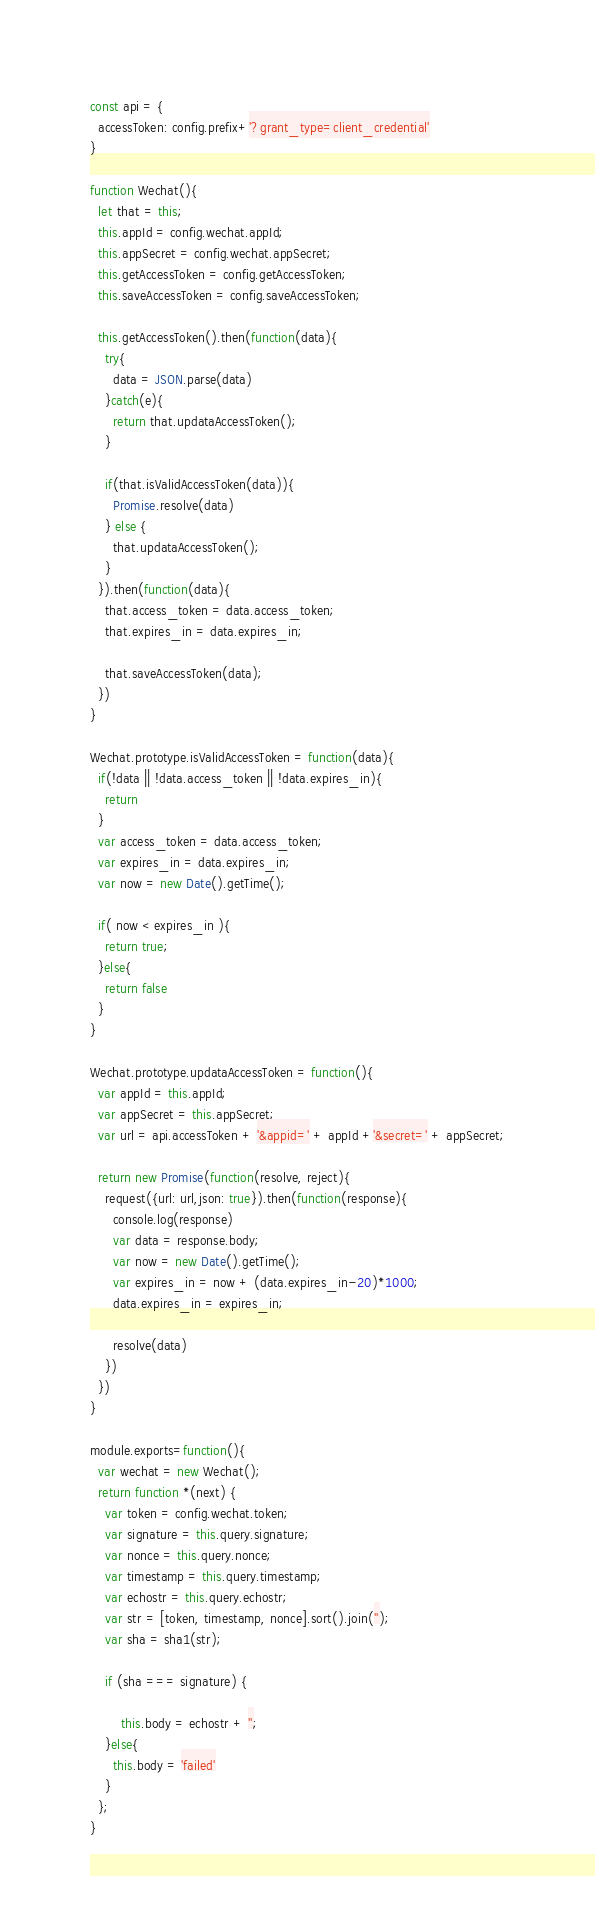Convert code to text. <code><loc_0><loc_0><loc_500><loc_500><_JavaScript_>
const api = {
  accessToken: config.prefix+'?grant_type=client_credential'
}

function Wechat(){
  let that = this;
  this.appId = config.wechat.appId;
  this.appSecret = config.wechat.appSecret;
  this.getAccessToken = config.getAccessToken;
  this.saveAccessToken = config.saveAccessToken;

  this.getAccessToken().then(function(data){
    try{
      data = JSON.parse(data)
    }catch(e){
      return that.updataAccessToken();
    }

    if(that.isValidAccessToken(data)){
      Promise.resolve(data)
    } else {
      that.updataAccessToken();
    }
  }).then(function(data){
    that.access_token = data.access_token;
    that.expires_in = data.expires_in;

    that.saveAccessToken(data);
  })
}

Wechat.prototype.isValidAccessToken = function(data){
  if(!data || !data.access_token || !data.expires_in){
    return 
  }
  var access_token = data.access_token;
  var expires_in = data.expires_in;
  var now = new Date().getTime();

  if( now < expires_in ){
    return true;
  }else{
    return false
  }
}

Wechat.prototype.updataAccessToken = function(){
  var appId = this.appId;
  var appSecret = this.appSecret;
  var url = api.accessToken + '&appid=' + appId +'&secret=' + appSecret;

  return new Promise(function(resolve, reject){
    request({url: url,json: true}).then(function(response){
      console.log(response)
      var data = response.body;
      var now = new Date().getTime();
      var expires_in = now + (data.expires_in-20)*1000;
      data.expires_in = expires_in;

      resolve(data)
    })
  })
}

module.exports=function(){
  var wechat = new Wechat();
  return function *(next) {
    var token = config.wechat.token;
    var signature = this.query.signature;
    var nonce = this.query.nonce;
    var timestamp = this.query.timestamp;
    var echostr = this.query.echostr;
    var str = [token, timestamp, nonce].sort().join('');
    var sha = sha1(str);

    if (sha === signature) {

        this.body = echostr + '';
    }else{
      this.body = 'failed'
    }
  };
}</code> 